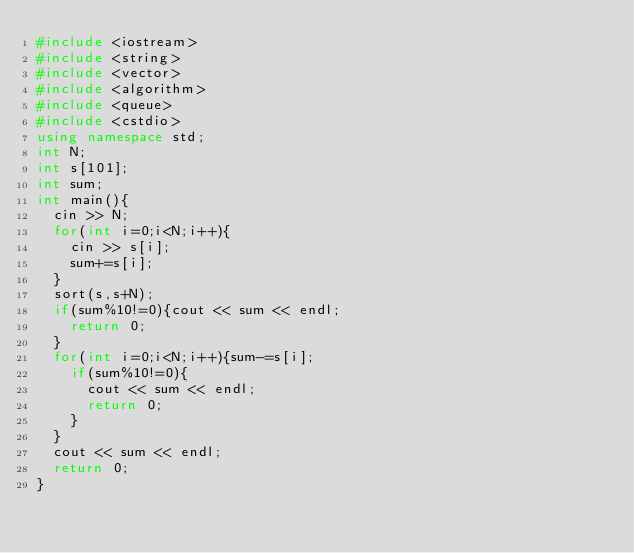Convert code to text. <code><loc_0><loc_0><loc_500><loc_500><_C++_>#include <iostream>
#include <string>
#include <vector>
#include <algorithm>
#include <queue>
#include <cstdio>
using namespace std;
int N;
int s[101];
int sum;
int main(){
  cin >> N;
  for(int i=0;i<N;i++){
    cin >> s[i];
    sum+=s[i];
  }
  sort(s,s+N);
  if(sum%10!=0){cout << sum << endl;
    return 0;
  }
  for(int i=0;i<N;i++){sum-=s[i];
    if(sum%10!=0){
      cout << sum << endl;
      return 0;
    }
  }
  cout << sum << endl;
  return 0;
}
</code> 